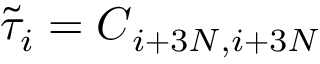<formula> <loc_0><loc_0><loc_500><loc_500>\tilde { \tau } _ { i } = C _ { i + 3 N , i + 3 N }</formula> 